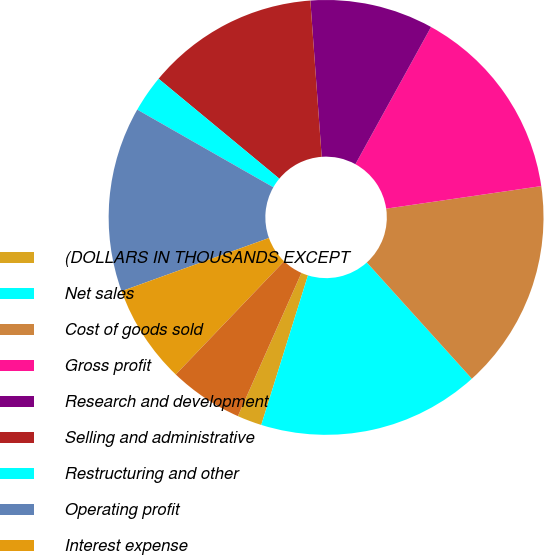Convert chart. <chart><loc_0><loc_0><loc_500><loc_500><pie_chart><fcel>(DOLLARS IN THOUSANDS EXCEPT<fcel>Net sales<fcel>Cost of goods sold<fcel>Gross profit<fcel>Research and development<fcel>Selling and administrative<fcel>Restructuring and other<fcel>Operating profit<fcel>Interest expense<fcel>Other expense (income) net<nl><fcel>1.83%<fcel>16.51%<fcel>15.6%<fcel>14.68%<fcel>9.17%<fcel>12.84%<fcel>2.75%<fcel>13.76%<fcel>7.34%<fcel>5.5%<nl></chart> 